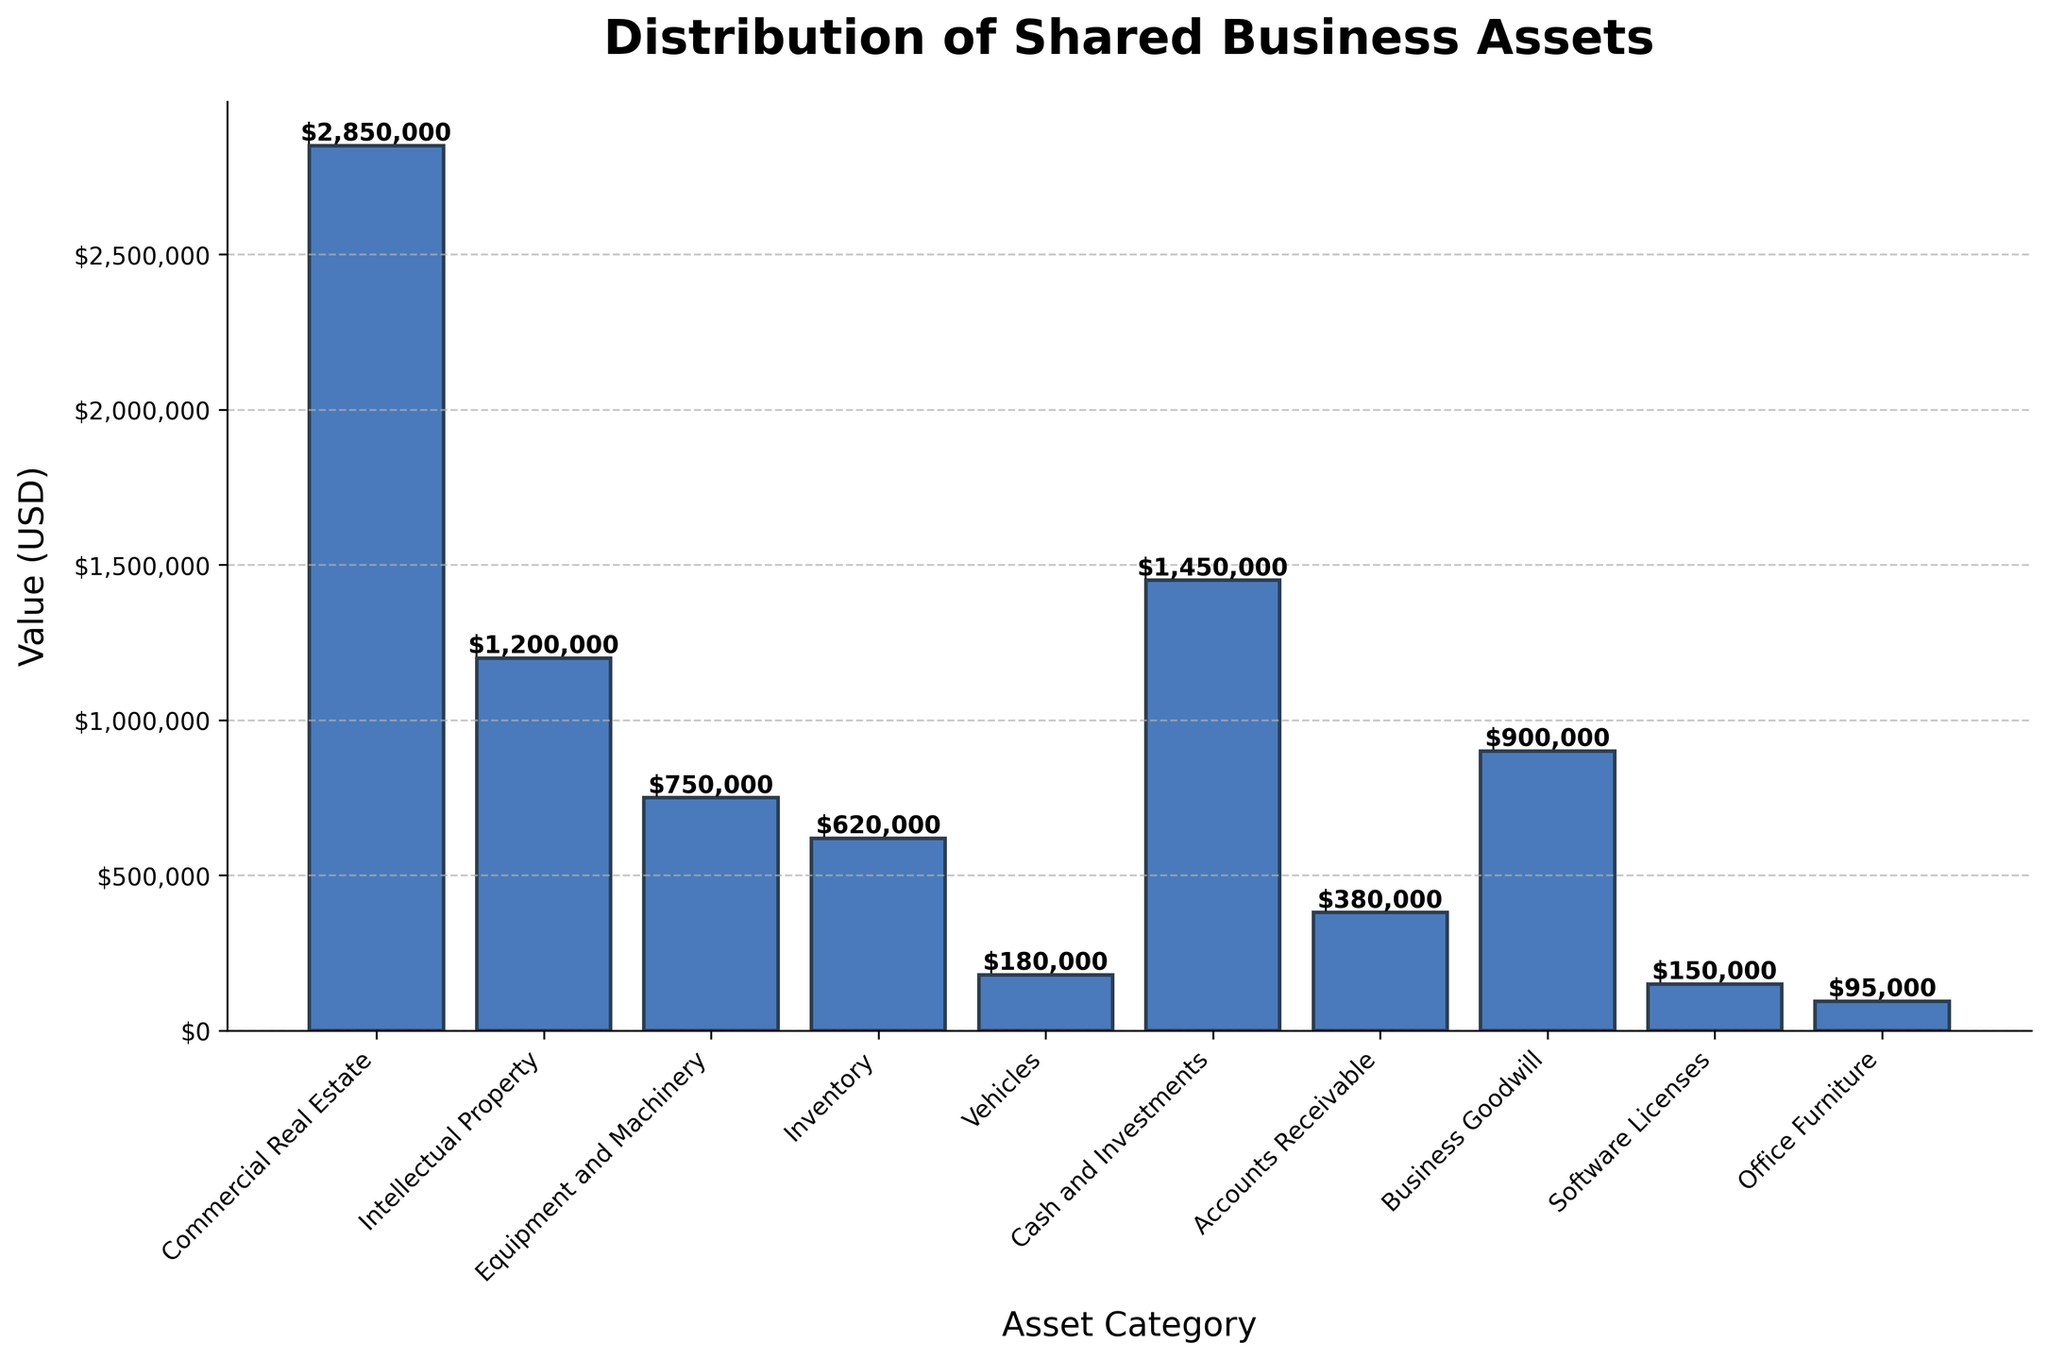what's the total value of the top three asset categories combined? First, identify the top three asset categories by their value: Commercial Real Estate ($2,850,000), Cash and Investments ($1,450,000), and Intellectual Property ($1,200,000). Add these values together: 2,850,000 + 1,450,000 + 1,200,000 = 5,500,000
Answer: $5,500,000 which asset category has the lowest value and how much is it? Identify the bar with the smallest height. Office Furniture has the lowest value of $95,000
Answer: Office Furniture, $95,000 how much more is the value of Equipment and Machinery compared to Vehicles? Locate the values of Equipment and Machinery ($750,000) and Vehicles ($180,000). Subtract the value of Vehicles from Equipment and Machinery: 750,000 - 180,000 = 570,000
Answer: $570,000 what is the average value of Inventory, Vehicles, and Office Furniture combined? Add the values of Inventory ($620,000), Vehicles ($180,000), and Office Furniture ($95,000): 620,000 + 180,000 + 95,000 = 895,000. Divide by 3 to find the average: 895,000 / 3 ≈ 298,333
Answer: $298,333 which asset categories have values higher than $1,000,000? Identify the bars with heights greater than $1,000,000: Commercial Real Estate ($2,850,000), Intellectual Property ($1,200,000), and Cash and Investments ($1,450,000)
Answer: Commercial Real Estate, Intellectual Property, Cash and Investments how much is the value of all assets combined? Add the values of all asset categories: 2,850,000 (Commercial Real Estate) + 1,200,000 (Intellectual Property) + 750,000 (Equipment and Machinery) + 620,000 (Inventory) + 180,000 (Vehicles) + 1,450,000 (Cash and Investments) + 380,000 (Accounts Receivable) + 900,000 (Business Goodwill) + 150,000 (Software Licenses) + 95,000 (Office Furniture) = 8,575,000
Answer: $8,575,000 which asset category contributes exactly 900,000 USD to the total value? Locate the bar corresponding to $900,000. Business Goodwill has a value of $900,000
Answer: Business Goodwill what’s the difference in value between Intellectual Property and Business Goodwill combined and Commercial Real Estate alone? Combine the values of Intellectual Property ($1,200,000) and Business Goodwill ($900,000): 1,200,000 + 900,000 = 2,100,000. Subtract the value of Commercial Real Estate ($2,850,000): 2,850,000 - 2,100,000 = 750,000
Answer: $750,000 which asset category is represented by the tallest bar and what does it signify? Identify the category with the tallest bar: Commercial Real Estate. It signifies the highest value shared business asset among the categories listed
Answer: Commercial Real Estate, highest value between Cash and Investments and Accounts Receivable, which has a higher value and by how much? Locate the values: Cash and Investments ($1,450,000) and Accounts Receivable ($380,000). Subtract Accounts Receivable from Cash and Investments: 1,450,000 - 380,000 = 1,070,000
Answer: Cash and Investments, $1,070,000 